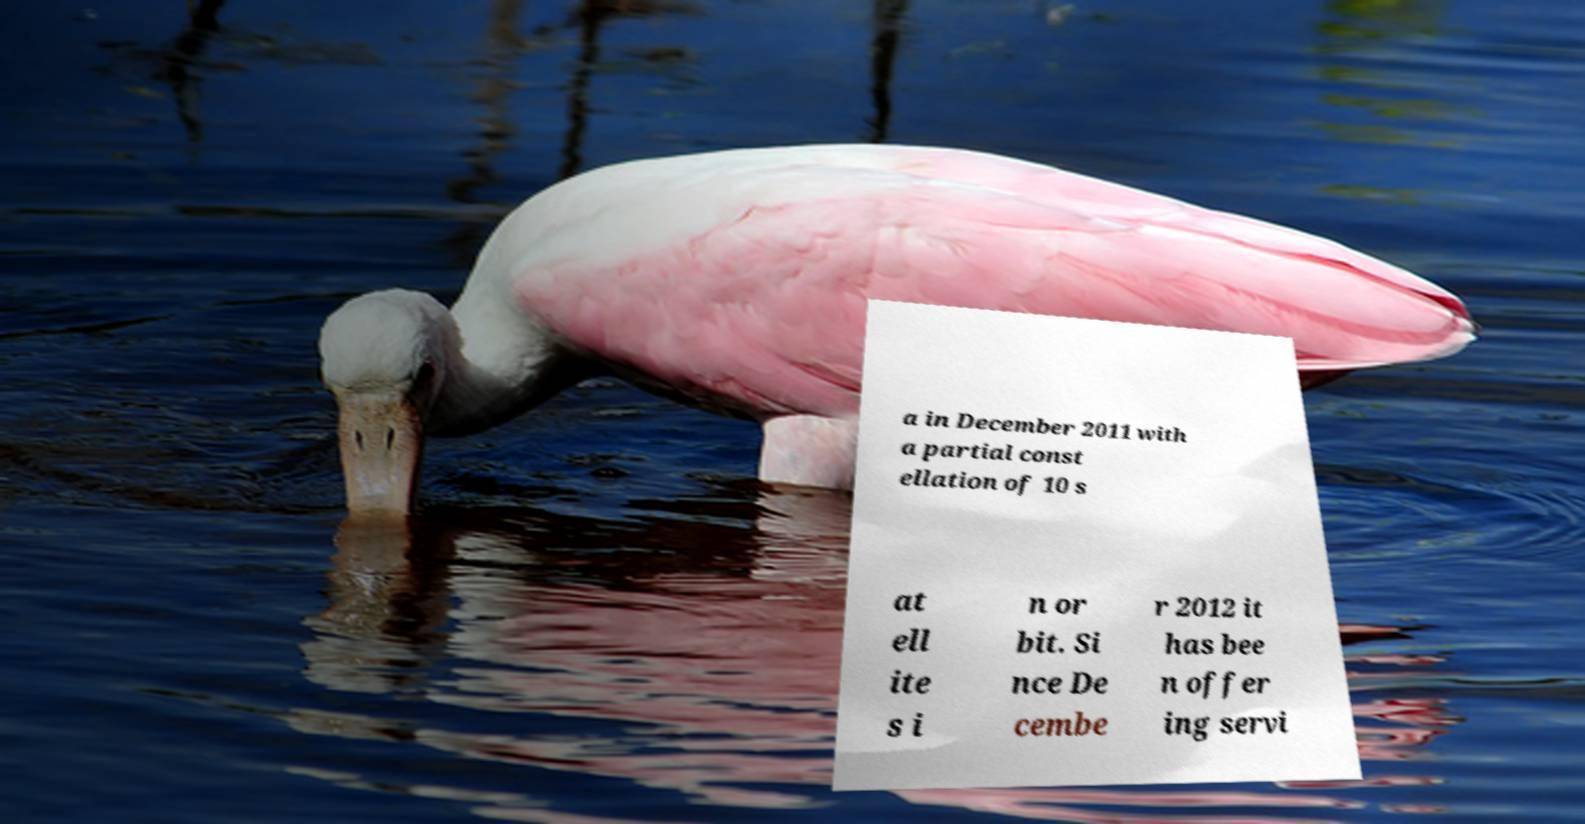Please read and relay the text visible in this image. What does it say? a in December 2011 with a partial const ellation of 10 s at ell ite s i n or bit. Si nce De cembe r 2012 it has bee n offer ing servi 